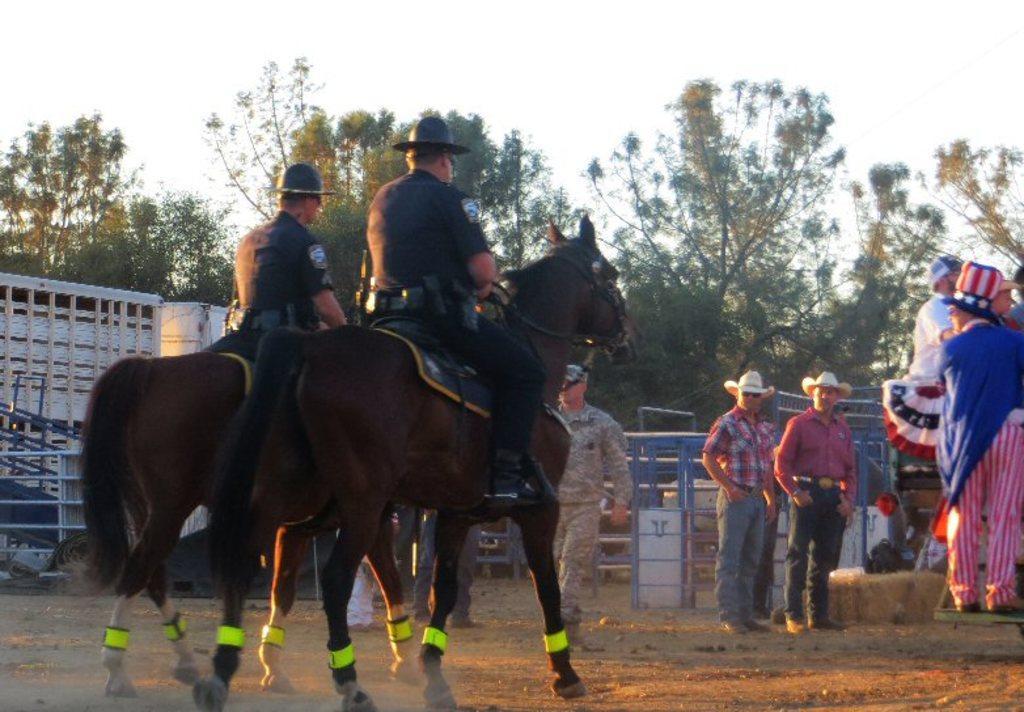Can you describe this image briefly? This is an outside view. On the left side two persons are sitting on two horses facing towards the back side. On the right side there are few people standing on the ground. In the background there is a railing and many trees. At the top of the image I can see the sky. 